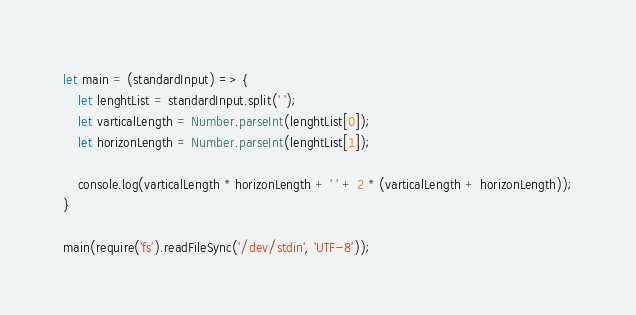Convert code to text. <code><loc_0><loc_0><loc_500><loc_500><_JavaScript_>let main = (standardInput) => {
    let lenghtList = standardInput.split(' ');
    let varticalLength = Number.parseInt(lenghtList[0]);
    let horizonLength = Number.parseInt(lenghtList[1]);

    console.log(varticalLength * horizonLength + ' ' + 2 * (varticalLength + horizonLength));
}

main(require('fs').readFileSync('/dev/stdin', 'UTF-8'));

</code> 